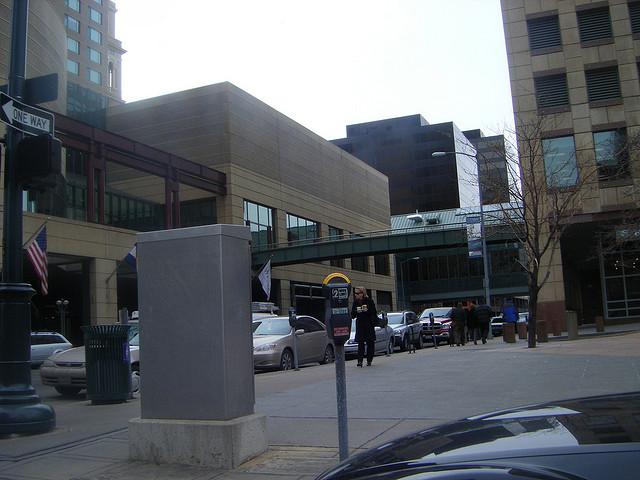Can you see a parking meter?
Give a very brief answer. Yes. What country's flag is in this photo?
Concise answer only. Usa. Is there a trash can in this image?
Be succinct. Yes. 